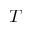Convert formula to latex. <formula><loc_0><loc_0><loc_500><loc_500>T</formula> 